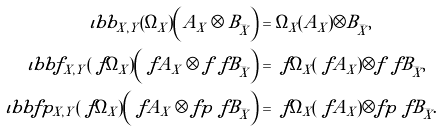<formula> <loc_0><loc_0><loc_500><loc_500>\iota b b _ { X , Y } ( \Omega _ { X } ) \left ( A _ { X } \otimes B _ { \bar { X } } \right ) & = \Omega _ { X } ( A _ { X } ) \otimes B _ { \bar { X } } , \\ \iota b b f _ { X , Y } ( \ f { \Omega } _ { X } ) \left ( \ f { A } _ { X } \otimes f \ f { B } _ { \bar { X } } \right ) & = \ f { \Omega } _ { X } ( \ f { A } _ { X } ) \otimes f \ f { B } _ { \bar { X } } , \\ \iota b b f p _ { X , Y } ( \ f { \Omega } _ { X } ) \left ( \ f { A } _ { X } \otimes f p \ f { B } _ { \bar { X } } \right ) & = \ f { \Omega } _ { X } ( \ f { A } _ { X } ) \otimes f p \ f { B } _ { \bar { X } } .</formula> 